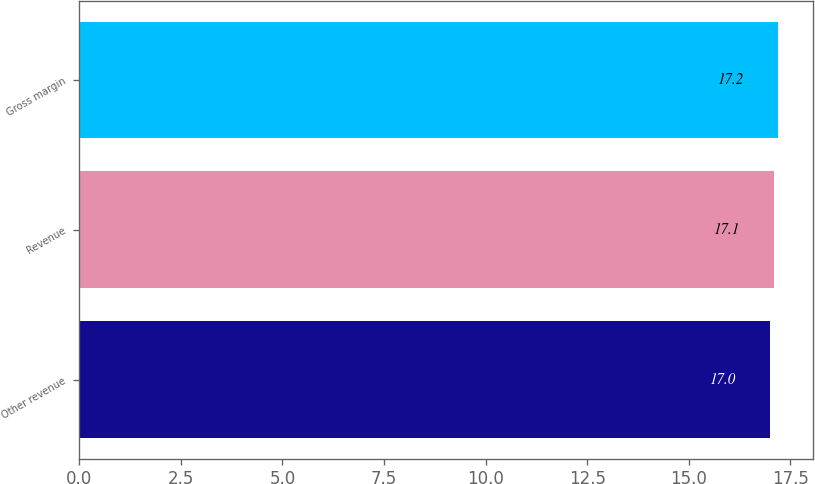<chart> <loc_0><loc_0><loc_500><loc_500><bar_chart><fcel>Other revenue<fcel>Revenue<fcel>Gross margin<nl><fcel>17<fcel>17.1<fcel>17.2<nl></chart> 